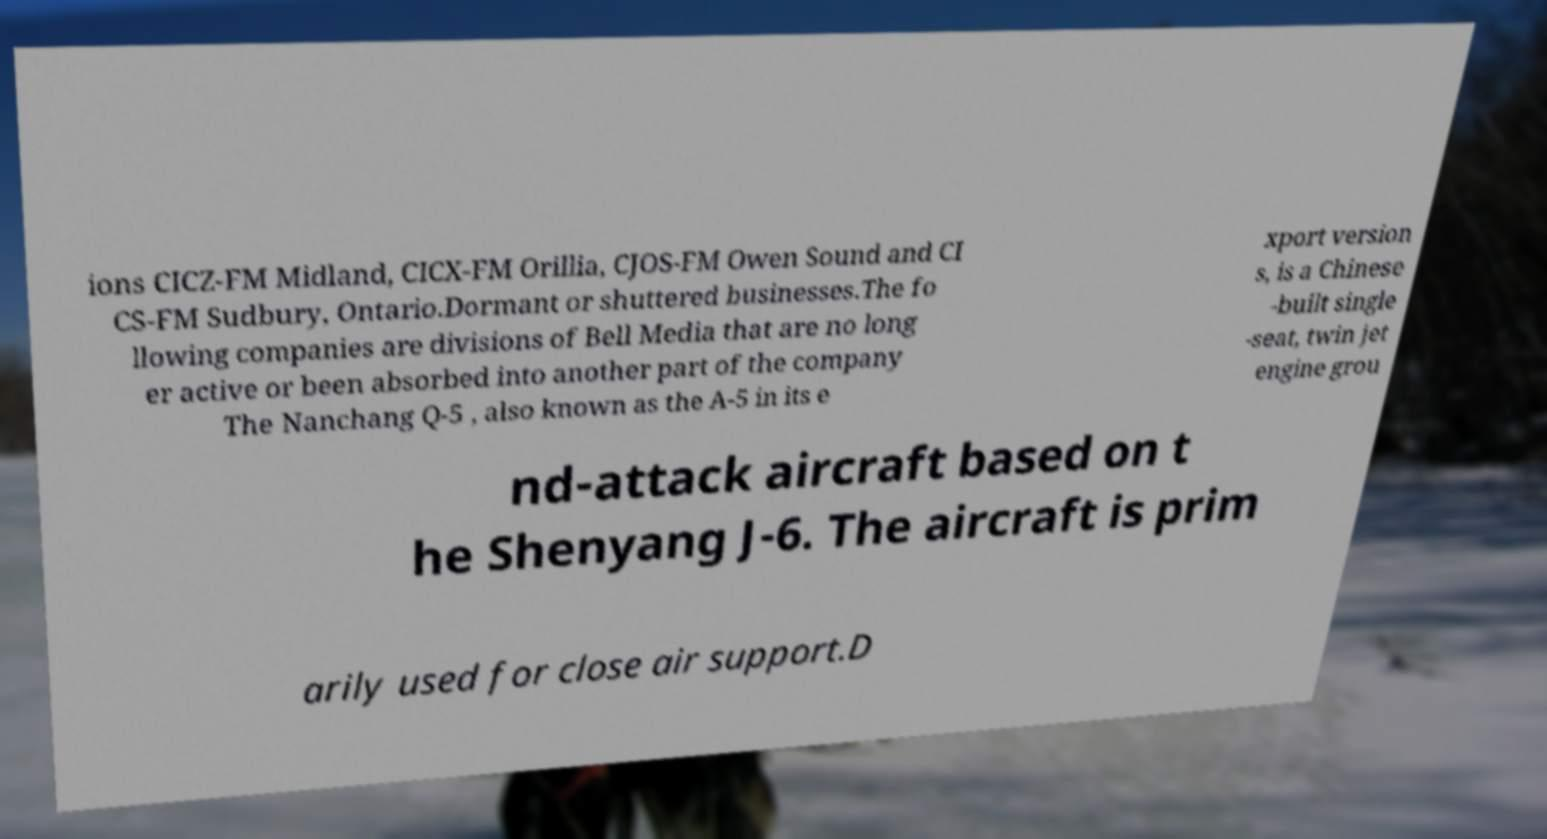Could you extract and type out the text from this image? ions CICZ-FM Midland, CICX-FM Orillia, CJOS-FM Owen Sound and CI CS-FM Sudbury, Ontario.Dormant or shuttered businesses.The fo llowing companies are divisions of Bell Media that are no long er active or been absorbed into another part of the company The Nanchang Q-5 , also known as the A-5 in its e xport version s, is a Chinese -built single -seat, twin jet engine grou nd-attack aircraft based on t he Shenyang J-6. The aircraft is prim arily used for close air support.D 